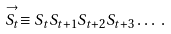Convert formula to latex. <formula><loc_0><loc_0><loc_500><loc_500>\stackrel { \rightarrow } { S _ { t } } \equiv S _ { t } S _ { t + 1 } S _ { t + 2 } S _ { t + 3 } \dots \, .</formula> 